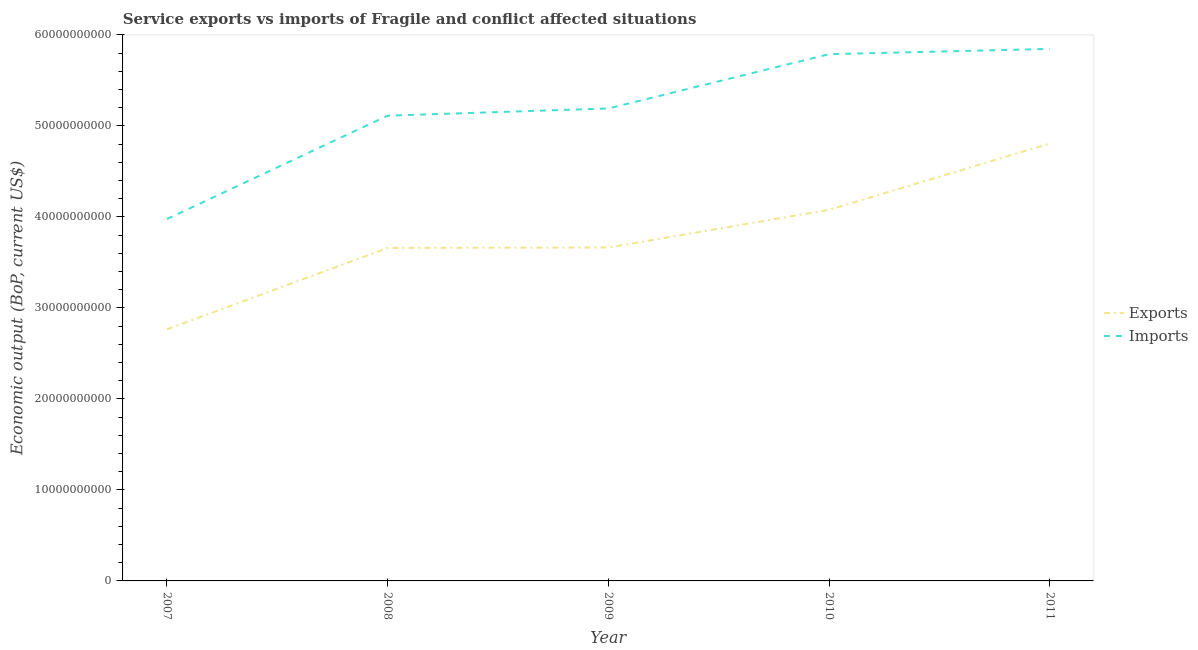Is the number of lines equal to the number of legend labels?
Your answer should be very brief. Yes. What is the amount of service imports in 2009?
Ensure brevity in your answer.  5.19e+1. Across all years, what is the maximum amount of service imports?
Make the answer very short. 5.85e+1. Across all years, what is the minimum amount of service imports?
Make the answer very short. 3.98e+1. In which year was the amount of service exports maximum?
Offer a terse response. 2011. In which year was the amount of service imports minimum?
Give a very brief answer. 2007. What is the total amount of service exports in the graph?
Provide a short and direct response. 1.90e+11. What is the difference between the amount of service exports in 2008 and that in 2011?
Your response must be concise. -1.15e+1. What is the difference between the amount of service exports in 2010 and the amount of service imports in 2008?
Offer a very short reply. -1.03e+1. What is the average amount of service exports per year?
Your response must be concise. 3.79e+1. In the year 2008, what is the difference between the amount of service imports and amount of service exports?
Ensure brevity in your answer.  1.45e+1. In how many years, is the amount of service imports greater than 48000000000 US$?
Your answer should be very brief. 4. What is the ratio of the amount of service imports in 2009 to that in 2011?
Offer a very short reply. 0.89. Is the amount of service imports in 2007 less than that in 2009?
Offer a terse response. Yes. Is the difference between the amount of service imports in 2007 and 2009 greater than the difference between the amount of service exports in 2007 and 2009?
Offer a terse response. No. What is the difference between the highest and the second highest amount of service exports?
Provide a short and direct response. 7.28e+09. What is the difference between the highest and the lowest amount of service exports?
Make the answer very short. 2.04e+1. In how many years, is the amount of service exports greater than the average amount of service exports taken over all years?
Ensure brevity in your answer.  2. Is the sum of the amount of service exports in 2008 and 2010 greater than the maximum amount of service imports across all years?
Your answer should be compact. Yes. Does the amount of service imports monotonically increase over the years?
Provide a short and direct response. Yes. Is the amount of service exports strictly greater than the amount of service imports over the years?
Give a very brief answer. No. How many years are there in the graph?
Your response must be concise. 5. What is the difference between two consecutive major ticks on the Y-axis?
Provide a succinct answer. 1.00e+1. Does the graph contain any zero values?
Your response must be concise. No. Where does the legend appear in the graph?
Offer a terse response. Center right. How are the legend labels stacked?
Keep it short and to the point. Vertical. What is the title of the graph?
Offer a very short reply. Service exports vs imports of Fragile and conflict affected situations. What is the label or title of the X-axis?
Keep it short and to the point. Year. What is the label or title of the Y-axis?
Provide a short and direct response. Economic output (BoP, current US$). What is the Economic output (BoP, current US$) in Exports in 2007?
Your answer should be very brief. 2.76e+1. What is the Economic output (BoP, current US$) of Imports in 2007?
Keep it short and to the point. 3.98e+1. What is the Economic output (BoP, current US$) in Exports in 2008?
Make the answer very short. 3.66e+1. What is the Economic output (BoP, current US$) of Imports in 2008?
Provide a succinct answer. 5.11e+1. What is the Economic output (BoP, current US$) in Exports in 2009?
Keep it short and to the point. 3.66e+1. What is the Economic output (BoP, current US$) of Imports in 2009?
Offer a very short reply. 5.19e+1. What is the Economic output (BoP, current US$) in Exports in 2010?
Your answer should be very brief. 4.08e+1. What is the Economic output (BoP, current US$) of Imports in 2010?
Keep it short and to the point. 5.79e+1. What is the Economic output (BoP, current US$) of Exports in 2011?
Give a very brief answer. 4.81e+1. What is the Economic output (BoP, current US$) of Imports in 2011?
Your answer should be very brief. 5.85e+1. Across all years, what is the maximum Economic output (BoP, current US$) in Exports?
Your response must be concise. 4.81e+1. Across all years, what is the maximum Economic output (BoP, current US$) in Imports?
Provide a succinct answer. 5.85e+1. Across all years, what is the minimum Economic output (BoP, current US$) of Exports?
Provide a short and direct response. 2.76e+1. Across all years, what is the minimum Economic output (BoP, current US$) in Imports?
Offer a terse response. 3.98e+1. What is the total Economic output (BoP, current US$) in Exports in the graph?
Make the answer very short. 1.90e+11. What is the total Economic output (BoP, current US$) of Imports in the graph?
Make the answer very short. 2.59e+11. What is the difference between the Economic output (BoP, current US$) of Exports in 2007 and that in 2008?
Make the answer very short. -8.94e+09. What is the difference between the Economic output (BoP, current US$) in Imports in 2007 and that in 2008?
Provide a succinct answer. -1.14e+1. What is the difference between the Economic output (BoP, current US$) in Exports in 2007 and that in 2009?
Your response must be concise. -8.99e+09. What is the difference between the Economic output (BoP, current US$) in Imports in 2007 and that in 2009?
Give a very brief answer. -1.21e+1. What is the difference between the Economic output (BoP, current US$) in Exports in 2007 and that in 2010?
Ensure brevity in your answer.  -1.31e+1. What is the difference between the Economic output (BoP, current US$) in Imports in 2007 and that in 2010?
Make the answer very short. -1.81e+1. What is the difference between the Economic output (BoP, current US$) of Exports in 2007 and that in 2011?
Offer a terse response. -2.04e+1. What is the difference between the Economic output (BoP, current US$) of Imports in 2007 and that in 2011?
Your answer should be very brief. -1.87e+1. What is the difference between the Economic output (BoP, current US$) in Exports in 2008 and that in 2009?
Give a very brief answer. -4.49e+07. What is the difference between the Economic output (BoP, current US$) in Imports in 2008 and that in 2009?
Your response must be concise. -7.92e+08. What is the difference between the Economic output (BoP, current US$) in Exports in 2008 and that in 2010?
Keep it short and to the point. -4.19e+09. What is the difference between the Economic output (BoP, current US$) in Imports in 2008 and that in 2010?
Keep it short and to the point. -6.76e+09. What is the difference between the Economic output (BoP, current US$) of Exports in 2008 and that in 2011?
Provide a short and direct response. -1.15e+1. What is the difference between the Economic output (BoP, current US$) of Imports in 2008 and that in 2011?
Give a very brief answer. -7.34e+09. What is the difference between the Economic output (BoP, current US$) of Exports in 2009 and that in 2010?
Provide a short and direct response. -4.14e+09. What is the difference between the Economic output (BoP, current US$) of Imports in 2009 and that in 2010?
Provide a succinct answer. -5.96e+09. What is the difference between the Economic output (BoP, current US$) of Exports in 2009 and that in 2011?
Provide a succinct answer. -1.14e+1. What is the difference between the Economic output (BoP, current US$) in Imports in 2009 and that in 2011?
Your answer should be compact. -6.54e+09. What is the difference between the Economic output (BoP, current US$) in Exports in 2010 and that in 2011?
Make the answer very short. -7.28e+09. What is the difference between the Economic output (BoP, current US$) of Imports in 2010 and that in 2011?
Provide a short and direct response. -5.80e+08. What is the difference between the Economic output (BoP, current US$) in Exports in 2007 and the Economic output (BoP, current US$) in Imports in 2008?
Ensure brevity in your answer.  -2.35e+1. What is the difference between the Economic output (BoP, current US$) of Exports in 2007 and the Economic output (BoP, current US$) of Imports in 2009?
Provide a short and direct response. -2.43e+1. What is the difference between the Economic output (BoP, current US$) in Exports in 2007 and the Economic output (BoP, current US$) in Imports in 2010?
Ensure brevity in your answer.  -3.02e+1. What is the difference between the Economic output (BoP, current US$) of Exports in 2007 and the Economic output (BoP, current US$) of Imports in 2011?
Your answer should be very brief. -3.08e+1. What is the difference between the Economic output (BoP, current US$) in Exports in 2008 and the Economic output (BoP, current US$) in Imports in 2009?
Provide a short and direct response. -1.53e+1. What is the difference between the Economic output (BoP, current US$) of Exports in 2008 and the Economic output (BoP, current US$) of Imports in 2010?
Provide a short and direct response. -2.13e+1. What is the difference between the Economic output (BoP, current US$) of Exports in 2008 and the Economic output (BoP, current US$) of Imports in 2011?
Your answer should be very brief. -2.19e+1. What is the difference between the Economic output (BoP, current US$) in Exports in 2009 and the Economic output (BoP, current US$) in Imports in 2010?
Offer a terse response. -2.12e+1. What is the difference between the Economic output (BoP, current US$) of Exports in 2009 and the Economic output (BoP, current US$) of Imports in 2011?
Keep it short and to the point. -2.18e+1. What is the difference between the Economic output (BoP, current US$) of Exports in 2010 and the Economic output (BoP, current US$) of Imports in 2011?
Offer a very short reply. -1.77e+1. What is the average Economic output (BoP, current US$) of Exports per year?
Your answer should be very brief. 3.79e+1. What is the average Economic output (BoP, current US$) in Imports per year?
Offer a very short reply. 5.18e+1. In the year 2007, what is the difference between the Economic output (BoP, current US$) of Exports and Economic output (BoP, current US$) of Imports?
Give a very brief answer. -1.21e+1. In the year 2008, what is the difference between the Economic output (BoP, current US$) of Exports and Economic output (BoP, current US$) of Imports?
Ensure brevity in your answer.  -1.45e+1. In the year 2009, what is the difference between the Economic output (BoP, current US$) in Exports and Economic output (BoP, current US$) in Imports?
Provide a short and direct response. -1.53e+1. In the year 2010, what is the difference between the Economic output (BoP, current US$) of Exports and Economic output (BoP, current US$) of Imports?
Keep it short and to the point. -1.71e+1. In the year 2011, what is the difference between the Economic output (BoP, current US$) of Exports and Economic output (BoP, current US$) of Imports?
Offer a terse response. -1.04e+1. What is the ratio of the Economic output (BoP, current US$) of Exports in 2007 to that in 2008?
Your response must be concise. 0.76. What is the ratio of the Economic output (BoP, current US$) in Exports in 2007 to that in 2009?
Your response must be concise. 0.75. What is the ratio of the Economic output (BoP, current US$) of Imports in 2007 to that in 2009?
Your answer should be very brief. 0.77. What is the ratio of the Economic output (BoP, current US$) of Exports in 2007 to that in 2010?
Your answer should be compact. 0.68. What is the ratio of the Economic output (BoP, current US$) in Imports in 2007 to that in 2010?
Offer a terse response. 0.69. What is the ratio of the Economic output (BoP, current US$) in Exports in 2007 to that in 2011?
Offer a terse response. 0.58. What is the ratio of the Economic output (BoP, current US$) of Imports in 2007 to that in 2011?
Offer a terse response. 0.68. What is the ratio of the Economic output (BoP, current US$) of Exports in 2008 to that in 2009?
Your answer should be very brief. 1. What is the ratio of the Economic output (BoP, current US$) of Imports in 2008 to that in 2009?
Give a very brief answer. 0.98. What is the ratio of the Economic output (BoP, current US$) in Exports in 2008 to that in 2010?
Provide a succinct answer. 0.9. What is the ratio of the Economic output (BoP, current US$) of Imports in 2008 to that in 2010?
Your answer should be compact. 0.88. What is the ratio of the Economic output (BoP, current US$) of Exports in 2008 to that in 2011?
Offer a terse response. 0.76. What is the ratio of the Economic output (BoP, current US$) of Imports in 2008 to that in 2011?
Give a very brief answer. 0.87. What is the ratio of the Economic output (BoP, current US$) of Exports in 2009 to that in 2010?
Give a very brief answer. 0.9. What is the ratio of the Economic output (BoP, current US$) in Imports in 2009 to that in 2010?
Ensure brevity in your answer.  0.9. What is the ratio of the Economic output (BoP, current US$) in Exports in 2009 to that in 2011?
Keep it short and to the point. 0.76. What is the ratio of the Economic output (BoP, current US$) in Imports in 2009 to that in 2011?
Give a very brief answer. 0.89. What is the ratio of the Economic output (BoP, current US$) of Exports in 2010 to that in 2011?
Your answer should be very brief. 0.85. What is the difference between the highest and the second highest Economic output (BoP, current US$) of Exports?
Offer a very short reply. 7.28e+09. What is the difference between the highest and the second highest Economic output (BoP, current US$) of Imports?
Your answer should be very brief. 5.80e+08. What is the difference between the highest and the lowest Economic output (BoP, current US$) in Exports?
Keep it short and to the point. 2.04e+1. What is the difference between the highest and the lowest Economic output (BoP, current US$) in Imports?
Provide a succinct answer. 1.87e+1. 